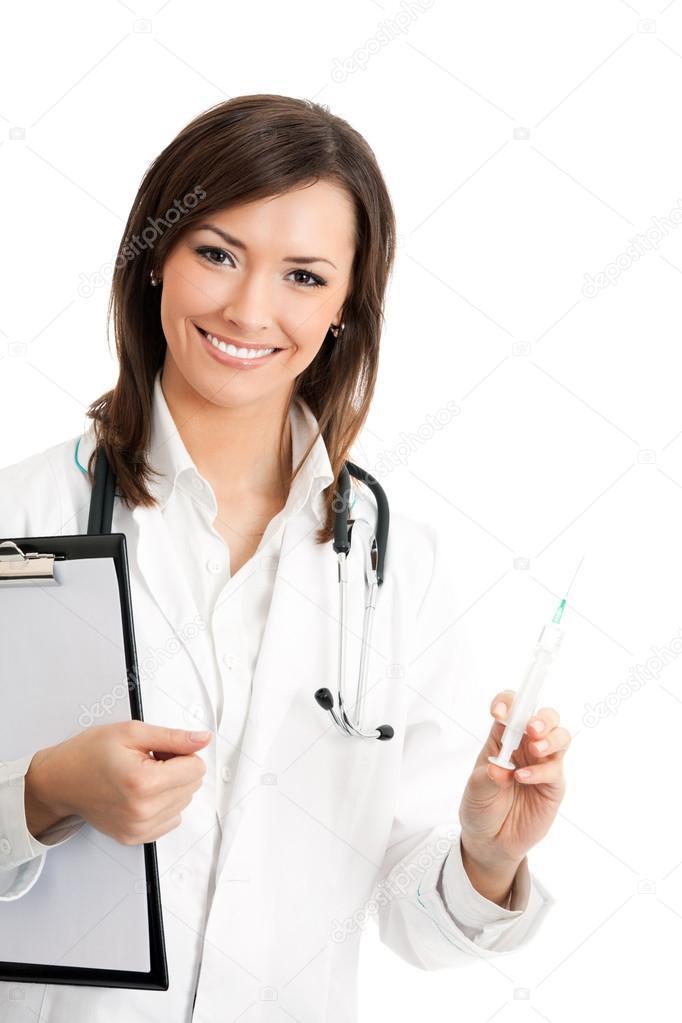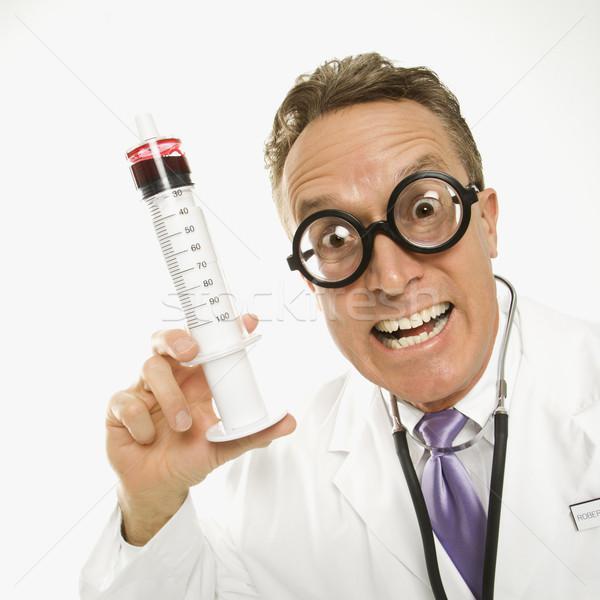The first image is the image on the left, the second image is the image on the right. Assess this claim about the two images: "Both doctors are women holding needles.". Correct or not? Answer yes or no. No. The first image is the image on the left, the second image is the image on the right. Assess this claim about the two images: "The left and right image contains the same number of women holding needles.". Correct or not? Answer yes or no. No. 